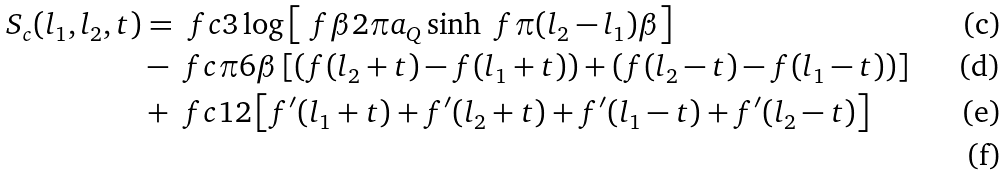Convert formula to latex. <formula><loc_0><loc_0><loc_500><loc_500>S _ { c } ( l _ { 1 } , l _ { 2 } , t ) & = \ f { c } { 3 } \log \left [ \ f { \beta } { 2 \pi a _ { Q } } \sinh \ f { \pi ( l _ { 2 } - l _ { 1 } ) } { \beta } \right ] \\ & - \ f { c \pi } { 6 \beta } \left [ \left ( f ( l _ { 2 } + t ) - f ( l _ { 1 } + t ) \right ) + \left ( f ( l _ { 2 } - t ) - f ( l _ { 1 } - t ) \right ) \right ] \\ & + \ f { c } { 1 2 } \left [ f ^ { \prime } ( l _ { 1 } + t ) + f ^ { \prime } ( l _ { 2 } + t ) + f ^ { \prime } ( l _ { 1 } - t ) + f ^ { \prime } ( l _ { 2 } - t ) \right ] \\</formula> 